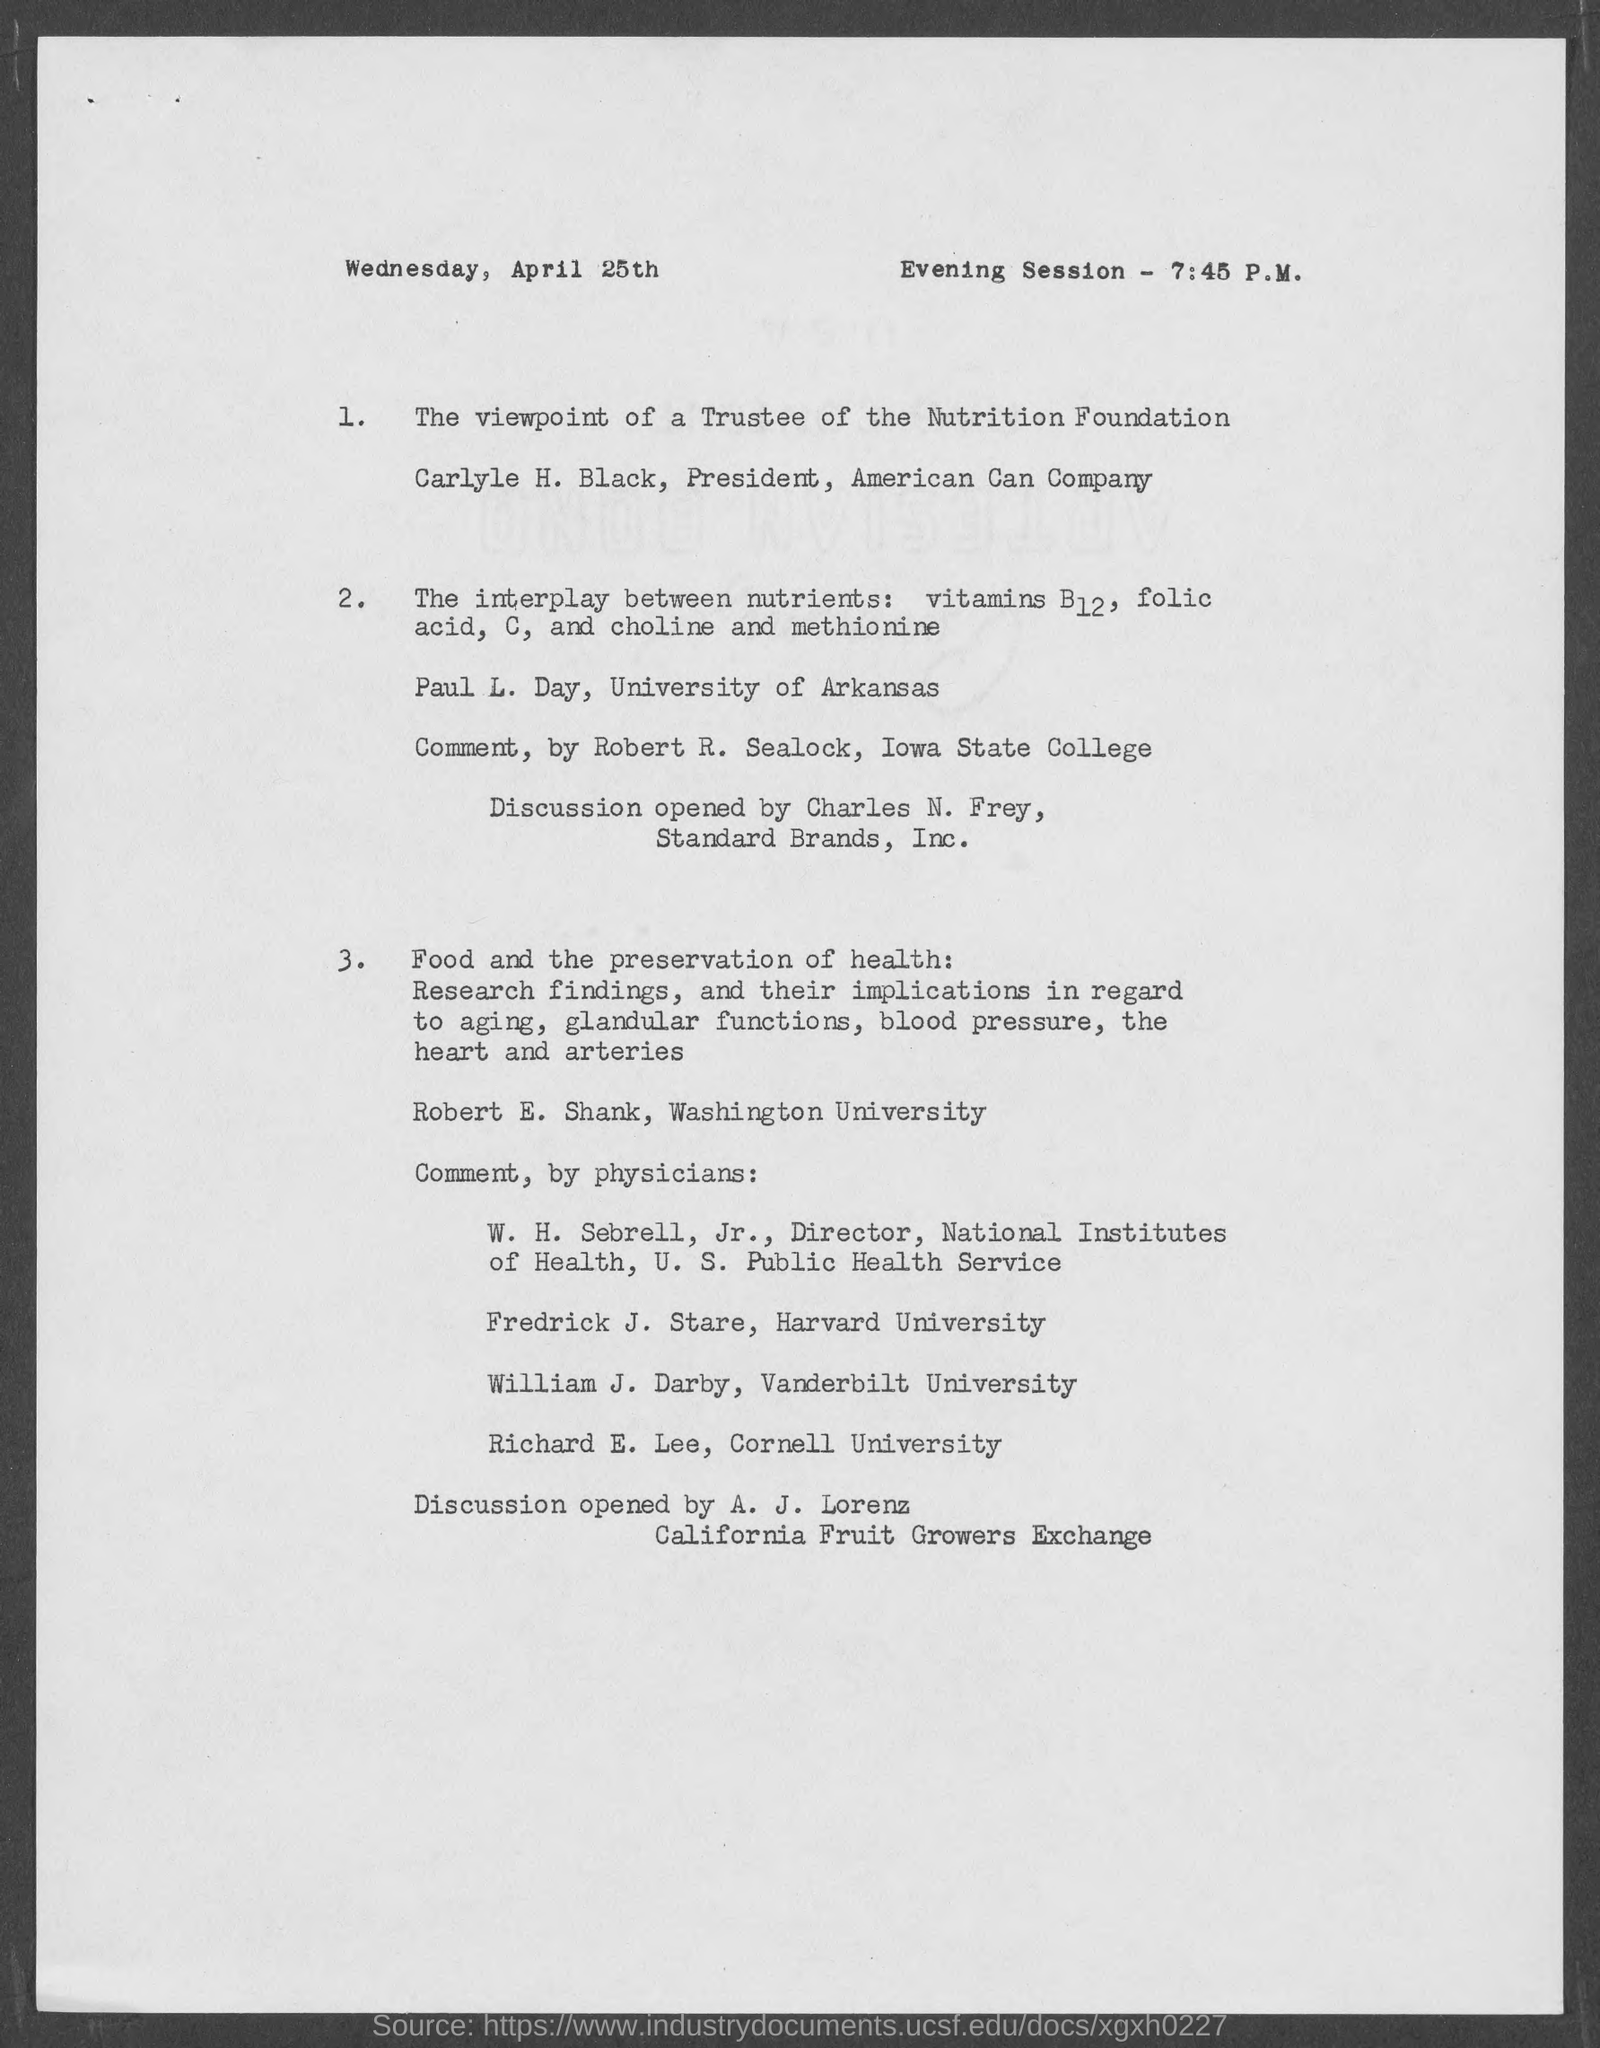List a handful of essential elements in this visual. Richard E. Lee is a part of Cornell University. The document is dated as of Wednesday, April 25th. Carlyle H. Black is the president of American Can Company. The person who will initiate the discussion is A. J. Lorenz. The evening session is scheduled to begin at 7:45 P.M. 